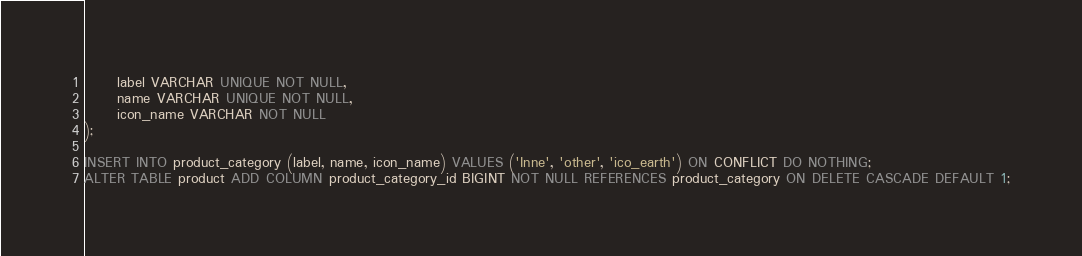Convert code to text. <code><loc_0><loc_0><loc_500><loc_500><_SQL_>      label VARCHAR UNIQUE NOT NULL,
      name VARCHAR UNIQUE NOT NULL,
      icon_name VARCHAR NOT NULL
);

INSERT INTO product_category (label, name, icon_name) VALUES ('Inne', 'other', 'ico_earth') ON CONFLICT DO NOTHING;
ALTER TABLE product ADD COLUMN product_category_id BIGINT NOT NULL REFERENCES product_category ON DELETE CASCADE DEFAULT 1;</code> 